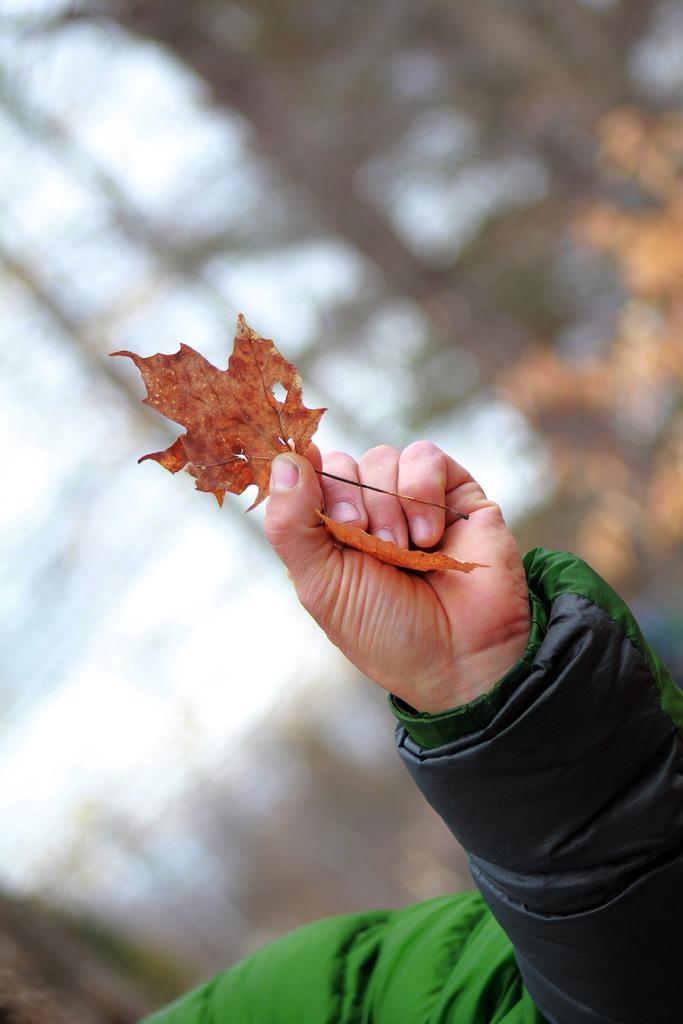How would you summarize this image in a sentence or two? In the image we can see a hand. In the hand there are some leaves. Background of the image is blur. 